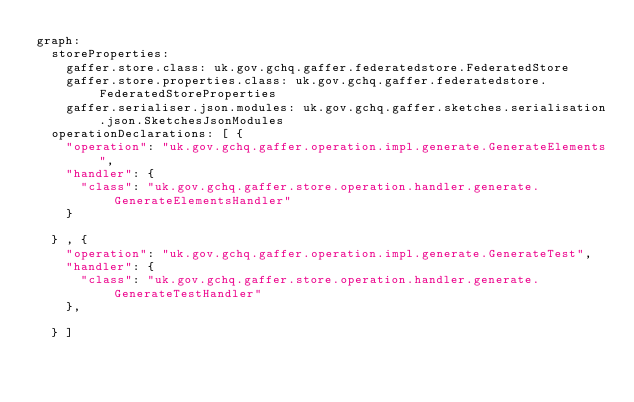Convert code to text. <code><loc_0><loc_0><loc_500><loc_500><_YAML_>graph:
  storeProperties:
    gaffer.store.class: uk.gov.gchq.gaffer.federatedstore.FederatedStore
    gaffer.store.properties.class: uk.gov.gchq.gaffer.federatedstore.FederatedStoreProperties
    gaffer.serialiser.json.modules: uk.gov.gchq.gaffer.sketches.serialisation.json.SketchesJsonModules
  operationDeclarations: [ {
    "operation": "uk.gov.gchq.gaffer.operation.impl.generate.GenerateElements",
    "handler": {
      "class": "uk.gov.gchq.gaffer.store.operation.handler.generate.GenerateElementsHandler"
    }

  } , {
    "operation": "uk.gov.gchq.gaffer.operation.impl.generate.GenerateTest",
    "handler": {
      "class": "uk.gov.gchq.gaffer.store.operation.handler.generate.GenerateTestHandler"
    },

  } ]</code> 